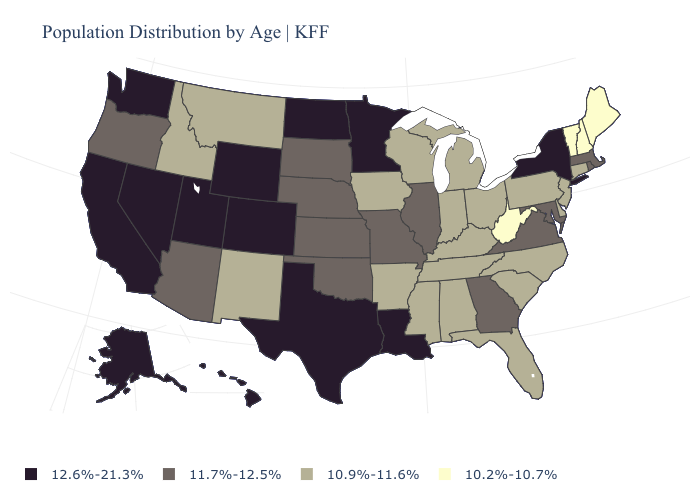Does Texas have the same value as Kentucky?
Give a very brief answer. No. What is the value of North Dakota?
Give a very brief answer. 12.6%-21.3%. Name the states that have a value in the range 11.7%-12.5%?
Give a very brief answer. Arizona, Georgia, Illinois, Kansas, Maryland, Massachusetts, Missouri, Nebraska, Oklahoma, Oregon, Rhode Island, South Dakota, Virginia. Is the legend a continuous bar?
Be succinct. No. Name the states that have a value in the range 11.7%-12.5%?
Write a very short answer. Arizona, Georgia, Illinois, Kansas, Maryland, Massachusetts, Missouri, Nebraska, Oklahoma, Oregon, Rhode Island, South Dakota, Virginia. Does North Carolina have the highest value in the USA?
Quick response, please. No. What is the lowest value in the USA?
Quick response, please. 10.2%-10.7%. What is the lowest value in the West?
Answer briefly. 10.9%-11.6%. Among the states that border Wyoming , does Montana have the lowest value?
Quick response, please. Yes. What is the highest value in the USA?
Be succinct. 12.6%-21.3%. What is the value of Oregon?
Be succinct. 11.7%-12.5%. Name the states that have a value in the range 11.7%-12.5%?
Write a very short answer. Arizona, Georgia, Illinois, Kansas, Maryland, Massachusetts, Missouri, Nebraska, Oklahoma, Oregon, Rhode Island, South Dakota, Virginia. What is the lowest value in states that border Georgia?
Give a very brief answer. 10.9%-11.6%. What is the value of South Dakota?
Answer briefly. 11.7%-12.5%. What is the value of Iowa?
Give a very brief answer. 10.9%-11.6%. 